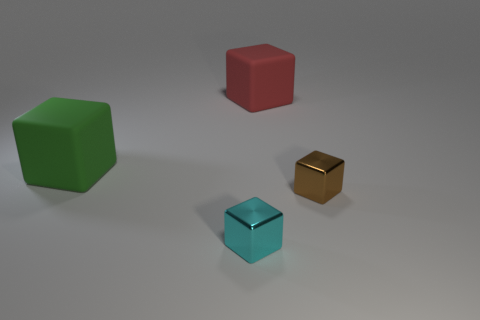Can you describe the texture and material of the objects? All the objects have a smooth and shiny texture, which suggests they might be made of a material like plastic or polished metal. 